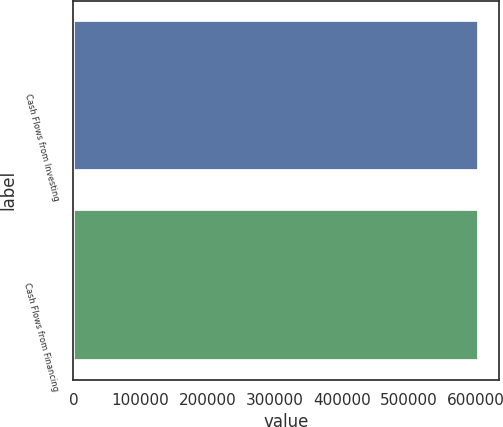Convert chart to OTSL. <chart><loc_0><loc_0><loc_500><loc_500><bar_chart><fcel>Cash Flows from Investing<fcel>Cash Flows from Financing<nl><fcel>604399<fcel>604399<nl></chart> 